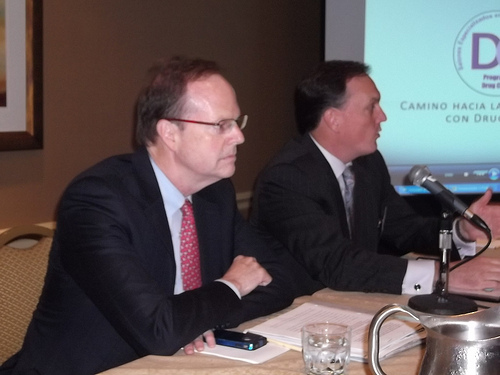<image>
Is the glasses on the person? No. The glasses is not positioned on the person. They may be near each other, but the glasses is not supported by or resting on top of the person. Is there a man talking in front of the on microphone? Yes. The man talking is positioned in front of the on microphone, appearing closer to the camera viewpoint. 